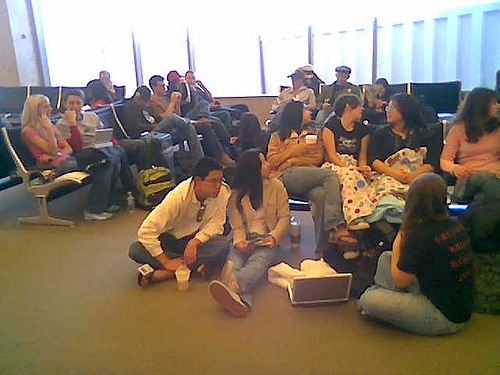Describe the objects in this image and their specific colors. I can see people in darkgray, black, gray, darkgreen, and maroon tones, people in darkgray, gray, black, and white tones, people in darkgray, tan, gray, maroon, and black tones, people in darkgray, gray, black, and brown tones, and people in darkgray, gray, brown, and maroon tones in this image. 